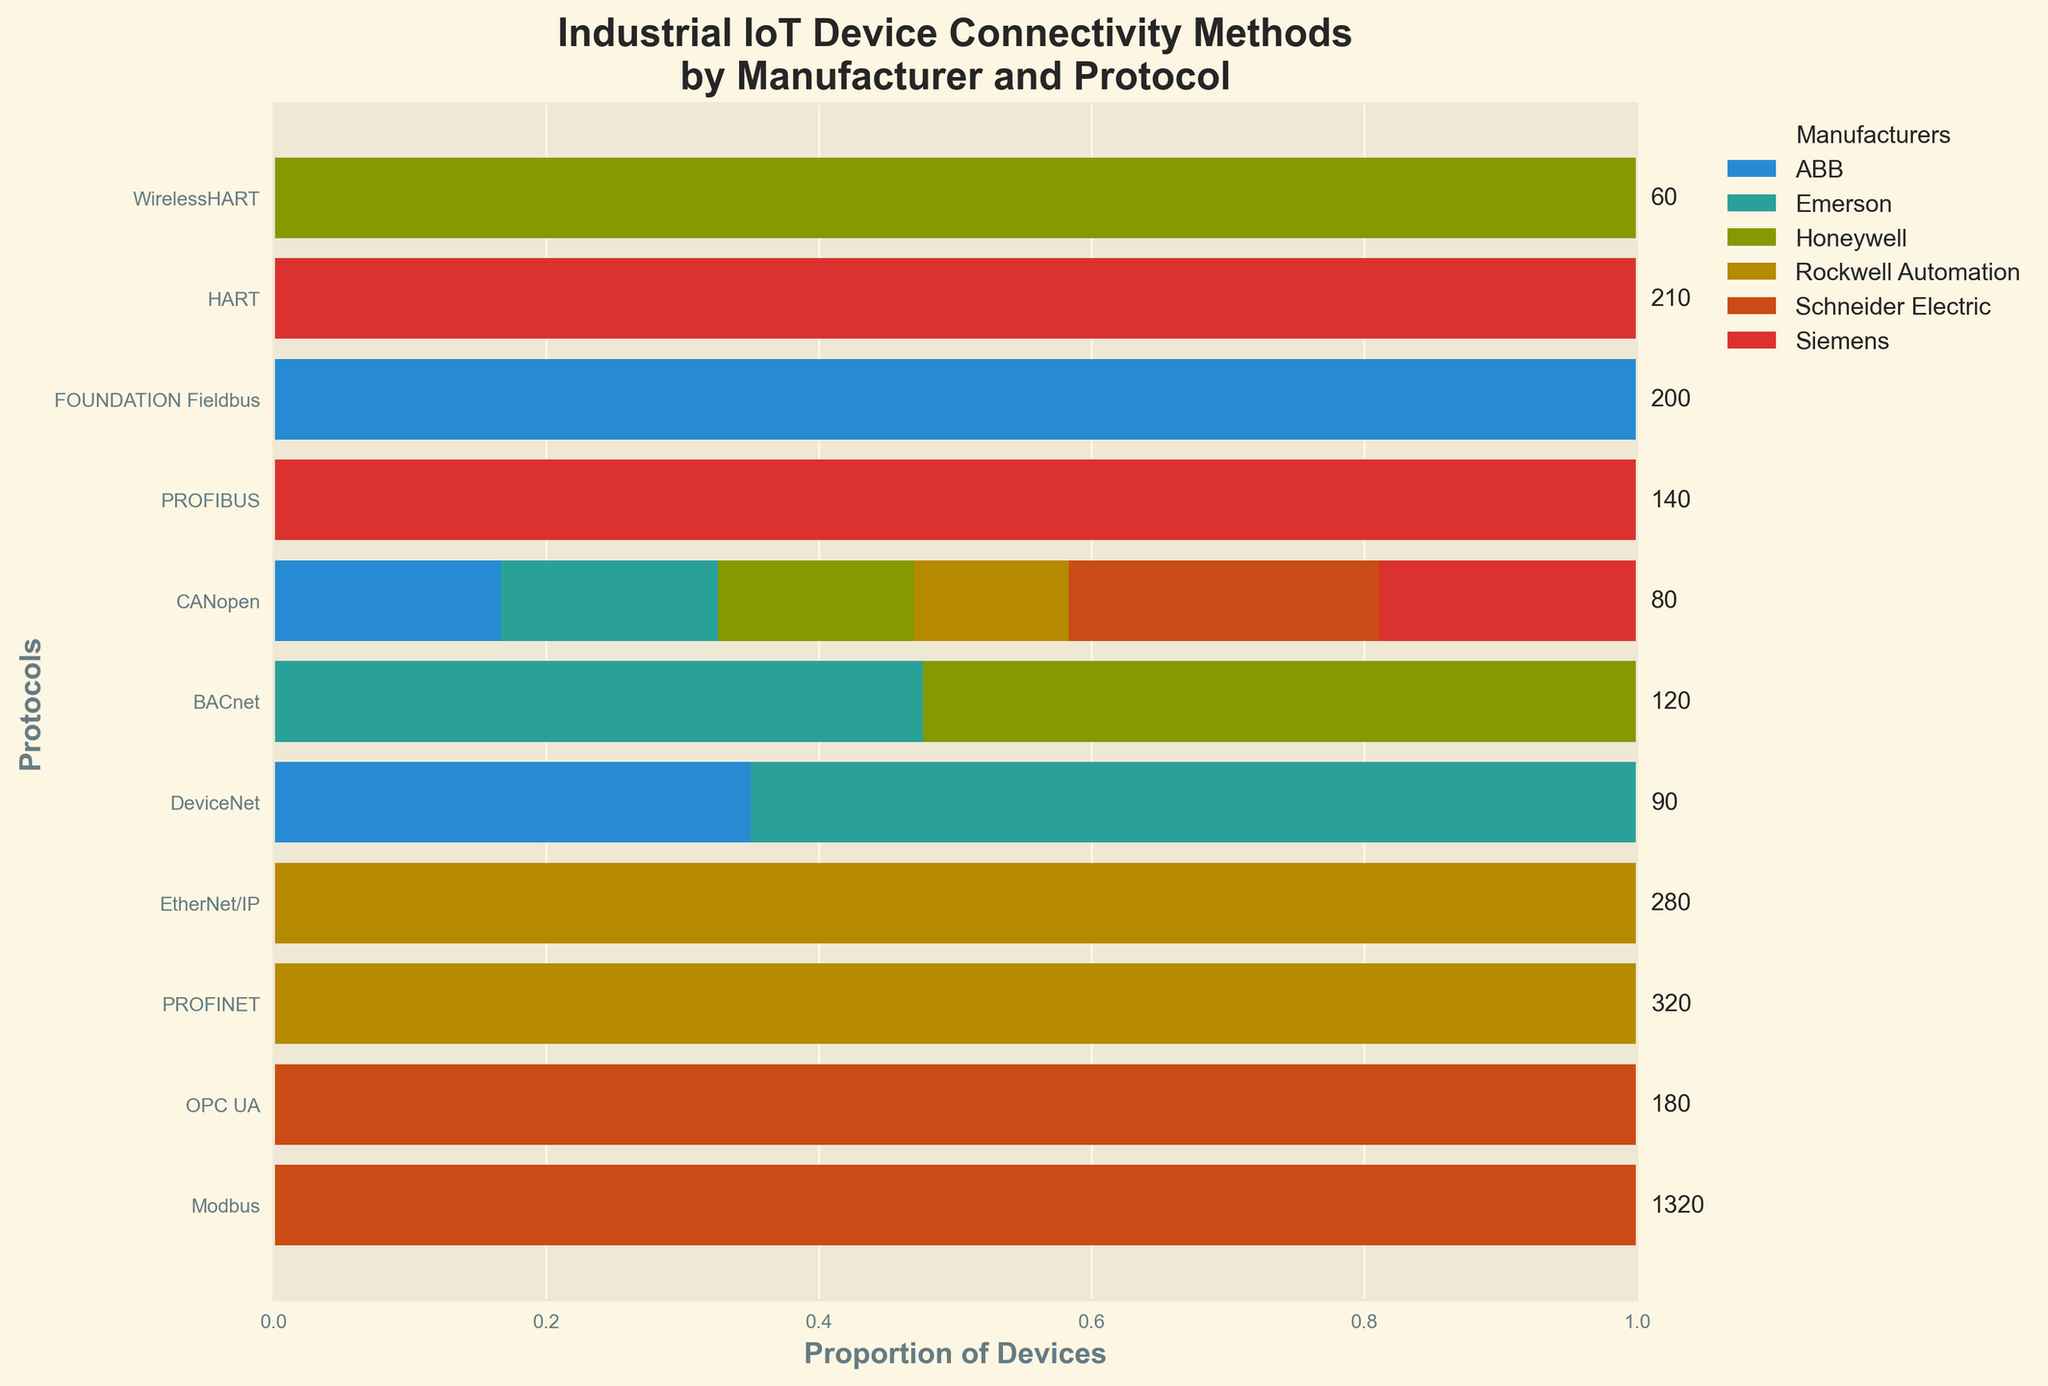Which manufacturer supports the most connectivity protocols? To find this, visually check which manufacturer appears most frequently across the protocols on the Mosaic Plot. Count the number of bars corresponding to each manufacturer.
Answer: Siemens Which protocol supports the highest number of devices in total? Sum up the number of devices across all manufacturers for each protocol as annotated on the plot. The protocol with the highest sum is the answer.
Answer: Modbus Which manufacturer has the smallest proportion of devices supporting DeviceNet? Look at the width of the bars representing DeviceNet for each manufacturer. The smallest width identifies the manufacturer in question.
Answer: Rockwell Automation What is the total number of devices supported by Rockwell Automation and Honeywell for all protocols combined? Sum up the device counts for Rockwell Automation and Honeywell across all protocols listed in the annotations near the protocols. Rockwell Automation: 280 + 150 + 90 = 520; Honeywell: 190 + 110 + 60 = 360; Total: 520 + 360 = 880.
Answer: 880 Which manufacturer has the largest proportion of devices supporting HART? Look at the width of the bars corresponding to HART for each manufacturer. The one with the largest width has the largest proportion.
Answer: Honeywell Does Schneider Electric support more devices using BACnet or CANopen? By how many more? Compare the bar lengths for BACnet and CANopen under Schneider Electric. BACnet: 120, CANopen: 80. Difference: 120 - 80 = 40.
Answer: BACnet, 40 Is the number of devices supporting PROFINET by Siemens greater than the number of devices supporting EtherNet/IP by Rockwell Automation? Refer to the annotations near the protocols to get the number of devices for PROFINET by Siemens (320) and EtherNet/IP by Rockwell Automation (280). Compare the two numbers.
Answer: Yes Which manufacturer supports the least number of devices for any single protocol? Look for the smallest bar across all protocols and manufacturers. The manufacturer represented by this smallest bar supports the least number of devices for that protocol.
Answer: Honeywell (WirelessHART) How many protocols are supported by ABB? Count the number of unique protocols that have any representation in the bars corresponding to ABB.
Answer: 3 What's the total number of devices supporting FOUNDATION Fieldbus protocol? Sum the number of devices for FOUNDATION Fieldbus under each manufacturer as annotated in the plot. FOUNDATION Fieldbus: 70 (ABB) + 130 (Emerson) = 200.
Answer: 200 